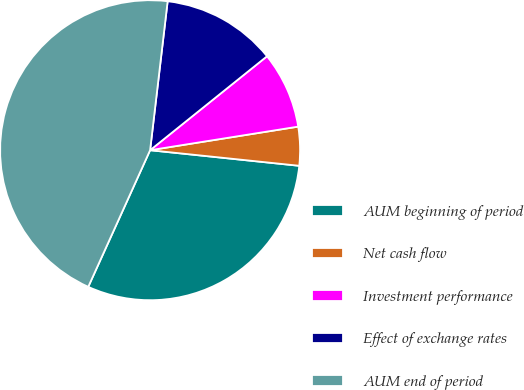<chart> <loc_0><loc_0><loc_500><loc_500><pie_chart><fcel>AUM beginning of period<fcel>Net cash flow<fcel>Investment performance<fcel>Effect of exchange rates<fcel>AUM end of period<nl><fcel>30.11%<fcel>4.17%<fcel>8.26%<fcel>12.36%<fcel>45.1%<nl></chart> 